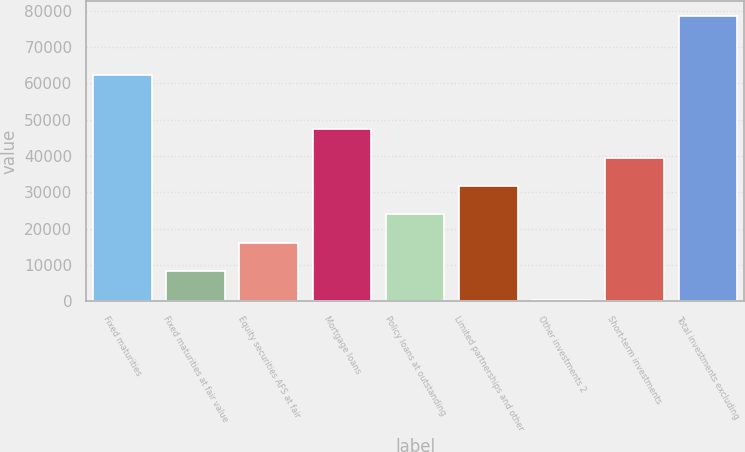<chart> <loc_0><loc_0><loc_500><loc_500><bar_chart><fcel>Fixed maturities<fcel>Fixed maturities at fair value<fcel>Equity securities AFS at fair<fcel>Mortgage loans<fcel>Policy loans at outstanding<fcel>Limited partnerships and other<fcel>Other investments 2<fcel>Short-term investments<fcel>Total investments excluding<nl><fcel>62357<fcel>8334.5<fcel>16148<fcel>47402<fcel>23961.5<fcel>31775<fcel>521<fcel>39588.5<fcel>78656<nl></chart> 